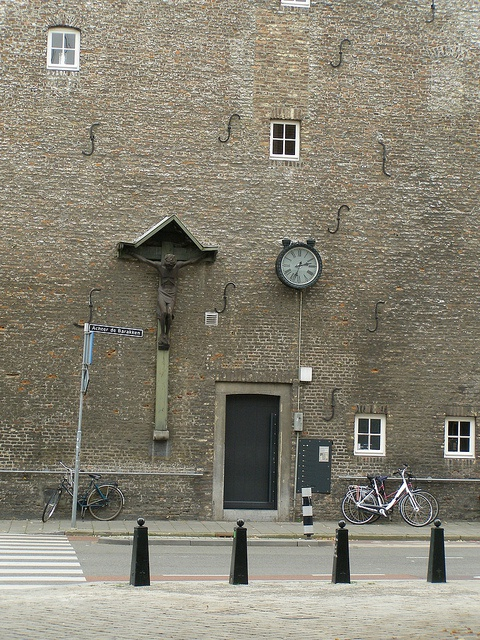Describe the objects in this image and their specific colors. I can see bicycle in lightgray, gray, black, and darkgray tones, bicycle in lightgray, gray, black, white, and darkgray tones, clock in lightgray, darkgray, gray, and black tones, and bicycle in lightgray, gray, black, and darkgray tones in this image. 